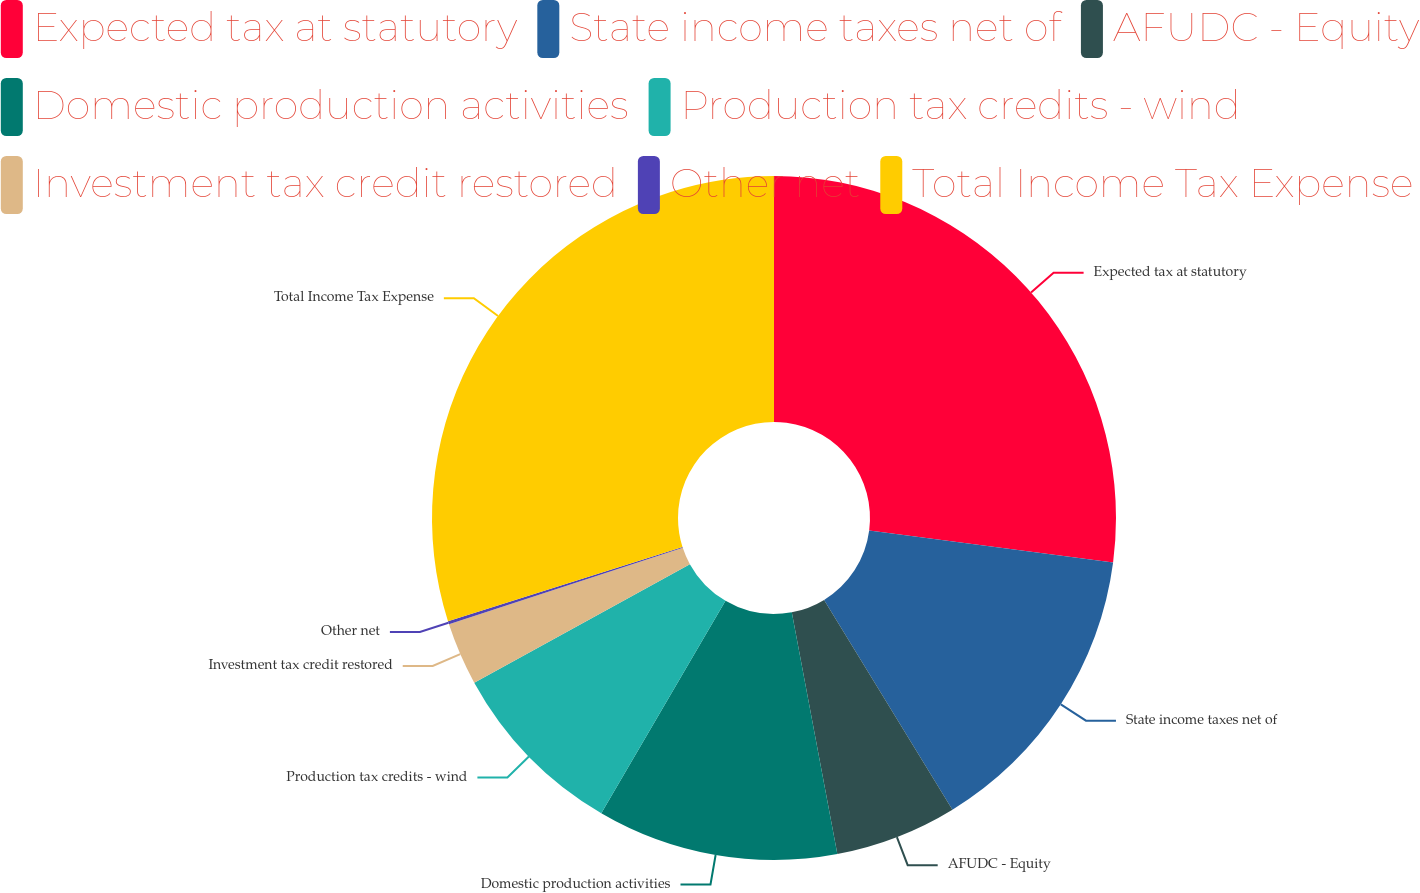Convert chart. <chart><loc_0><loc_0><loc_500><loc_500><pie_chart><fcel>Expected tax at statutory<fcel>State income taxes net of<fcel>AFUDC - Equity<fcel>Domestic production activities<fcel>Production tax credits - wind<fcel>Investment tax credit restored<fcel>Other net<fcel>Total Income Tax Expense<nl><fcel>27.07%<fcel>14.19%<fcel>5.77%<fcel>11.39%<fcel>8.58%<fcel>2.96%<fcel>0.15%<fcel>29.88%<nl></chart> 